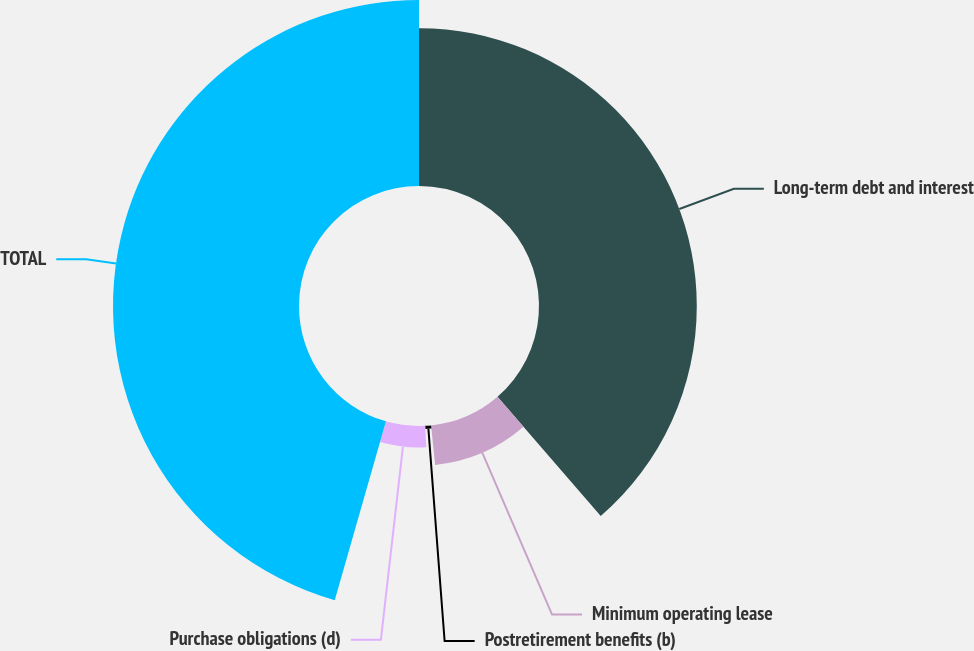<chart> <loc_0><loc_0><loc_500><loc_500><pie_chart><fcel>Long-term debt and interest<fcel>Minimum operating lease<fcel>Postretirement benefits (b)<fcel>Purchase obligations (d)<fcel>TOTAL<nl><fcel>38.65%<fcel>9.74%<fcel>0.79%<fcel>5.26%<fcel>45.56%<nl></chart> 